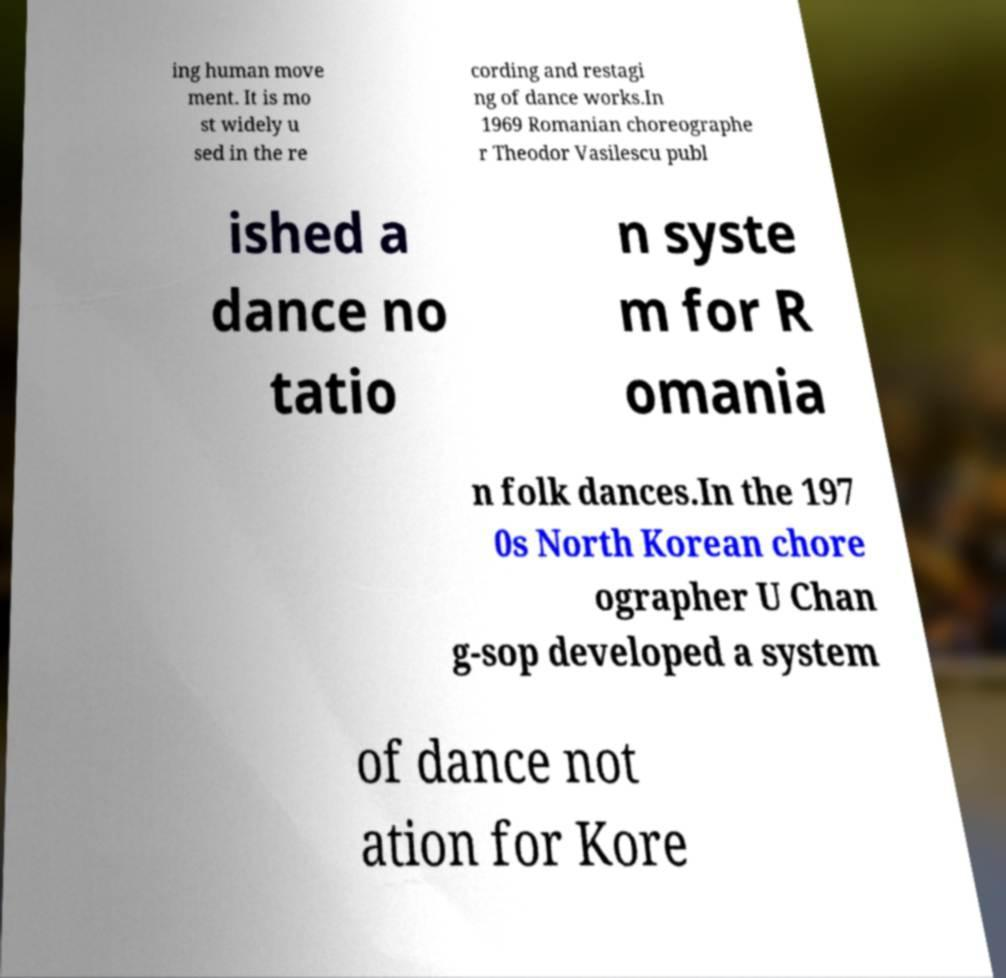Please identify and transcribe the text found in this image. ing human move ment. It is mo st widely u sed in the re cording and restagi ng of dance works.In 1969 Romanian choreographe r Theodor Vasilescu publ ished a dance no tatio n syste m for R omania n folk dances.In the 197 0s North Korean chore ographer U Chan g-sop developed a system of dance not ation for Kore 